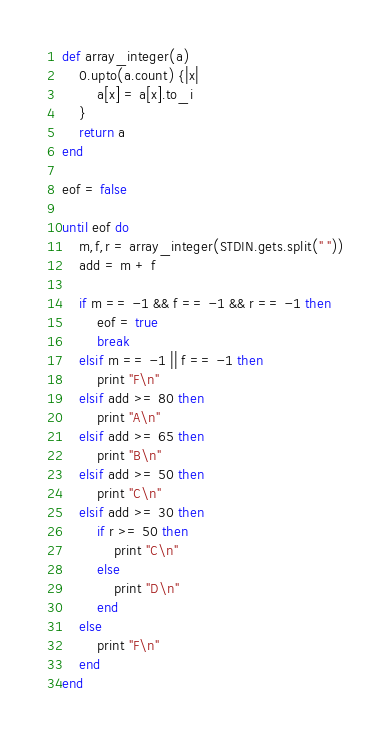Convert code to text. <code><loc_0><loc_0><loc_500><loc_500><_Ruby_>def array_integer(a)
	0.upto(a.count) {|x|
		a[x] = a[x].to_i
	}
	return a
end

eof = false

until eof do
	m,f,r = array_integer(STDIN.gets.split(" "))
	add = m + f
	
	if m == -1 && f == -1 && r == -1 then
		eof = true
		break
	elsif m == -1 || f == -1 then
		print "F\n"
	elsif add >= 80 then
		print "A\n"
	elsif add >= 65 then
		print "B\n"
	elsif add >= 50 then
		print "C\n"
	elsif add >= 30 then
		if r >= 50 then
			print "C\n"
		else
			print "D\n"
		end
	else
		print "F\n"
	end
end

</code> 